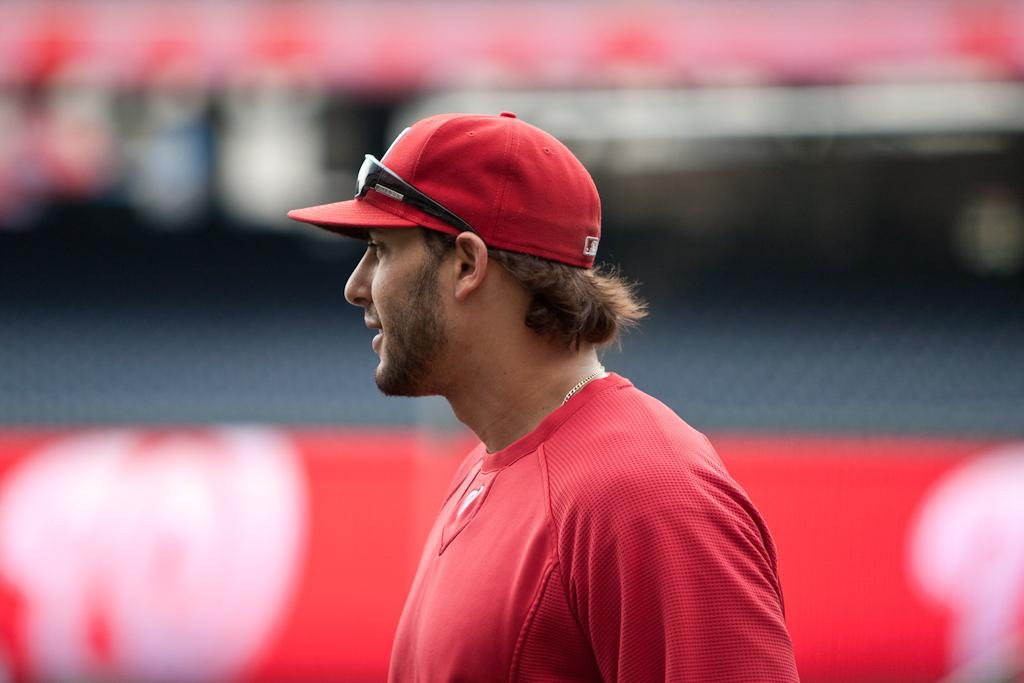What is the main subject of the picture? The main subject of the picture is a man. What is the man wearing on his head? The man is wearing a cap. Can you describe the background of the image? The background of the image is blurred. What type of amusement can be seen in the background of the image? There is no amusement present in the image; the background is blurred. What time of day is it in the image? The provided facts do not give any information about the time of day in the image. 